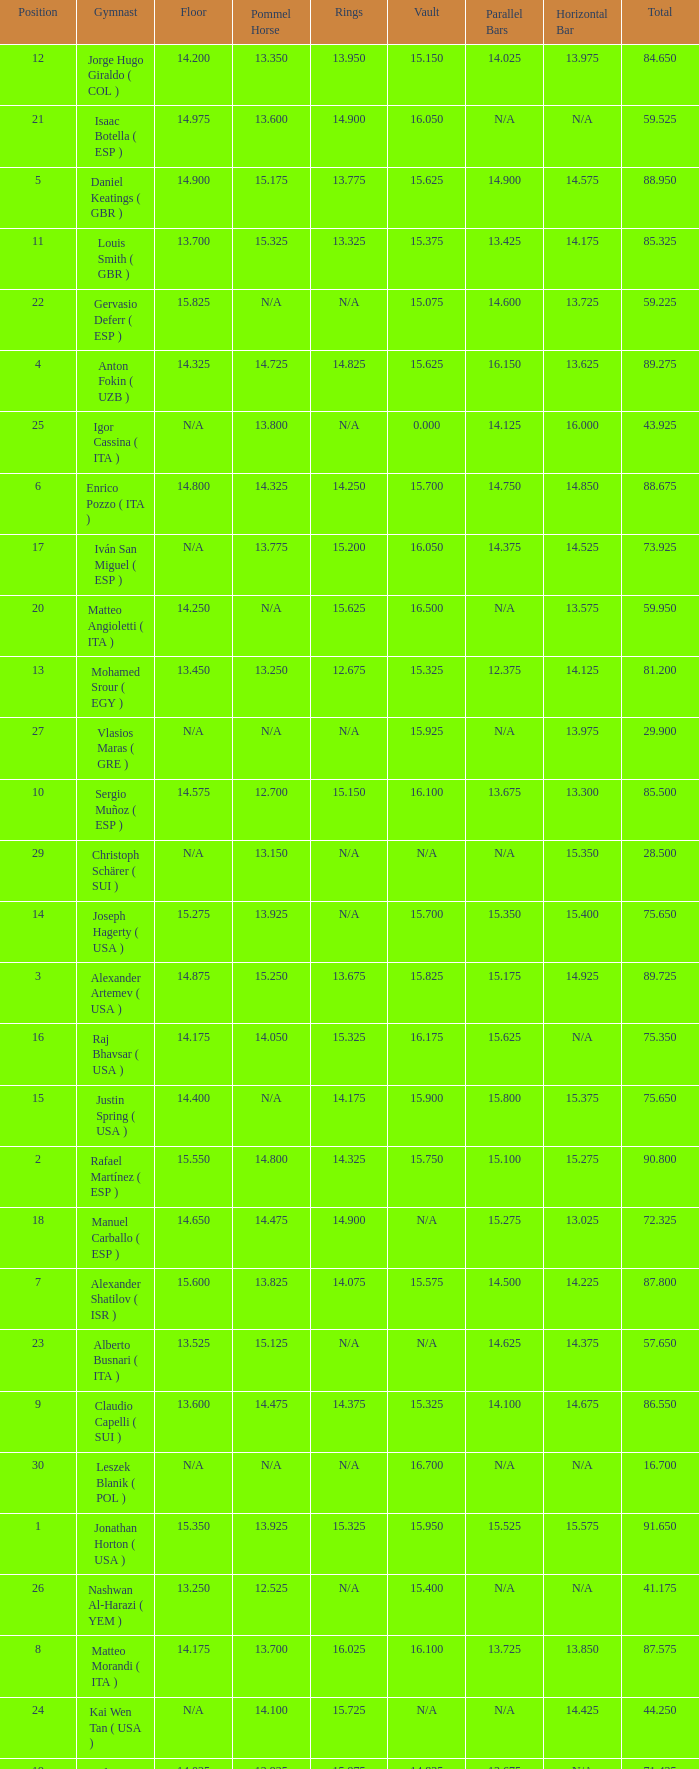Could you parse the entire table? {'header': ['Position', 'Gymnast', 'Floor', 'Pommel Horse', 'Rings', 'Vault', 'Parallel Bars', 'Horizontal Bar', 'Total'], 'rows': [['12', 'Jorge Hugo Giraldo ( COL )', '14.200', '13.350', '13.950', '15.150', '14.025', '13.975', '84.650'], ['21', 'Isaac Botella ( ESP )', '14.975', '13.600', '14.900', '16.050', 'N/A', 'N/A', '59.525'], ['5', 'Daniel Keatings ( GBR )', '14.900', '15.175', '13.775', '15.625', '14.900', '14.575', '88.950'], ['11', 'Louis Smith ( GBR )', '13.700', '15.325', '13.325', '15.375', '13.425', '14.175', '85.325'], ['22', 'Gervasio Deferr ( ESP )', '15.825', 'N/A', 'N/A', '15.075', '14.600', '13.725', '59.225'], ['4', 'Anton Fokin ( UZB )', '14.325', '14.725', '14.825', '15.625', '16.150', '13.625', '89.275'], ['25', 'Igor Cassina ( ITA )', 'N/A', '13.800', 'N/A', '0.000', '14.125', '16.000', '43.925'], ['6', 'Enrico Pozzo ( ITA )', '14.800', '14.325', '14.250', '15.700', '14.750', '14.850', '88.675'], ['17', 'Iván San Miguel ( ESP )', 'N/A', '13.775', '15.200', '16.050', '14.375', '14.525', '73.925'], ['20', 'Matteo Angioletti ( ITA )', '14.250', 'N/A', '15.625', '16.500', 'N/A', '13.575', '59.950'], ['13', 'Mohamed Srour ( EGY )', '13.450', '13.250', '12.675', '15.325', '12.375', '14.125', '81.200'], ['27', 'Vlasios Maras ( GRE )', 'N/A', 'N/A', 'N/A', '15.925', 'N/A', '13.975', '29.900'], ['10', 'Sergio Muñoz ( ESP )', '14.575', '12.700', '15.150', '16.100', '13.675', '13.300', '85.500'], ['29', 'Christoph Schärer ( SUI )', 'N/A', '13.150', 'N/A', 'N/A', 'N/A', '15.350', '28.500'], ['14', 'Joseph Hagerty ( USA )', '15.275', '13.925', 'N/A', '15.700', '15.350', '15.400', '75.650'], ['3', 'Alexander Artemev ( USA )', '14.875', '15.250', '13.675', '15.825', '15.175', '14.925', '89.725'], ['16', 'Raj Bhavsar ( USA )', '14.175', '14.050', '15.325', '16.175', '15.625', 'N/A', '75.350'], ['15', 'Justin Spring ( USA )', '14.400', 'N/A', '14.175', '15.900', '15.800', '15.375', '75.650'], ['2', 'Rafael Martínez ( ESP )', '15.550', '14.800', '14.325', '15.750', '15.100', '15.275', '90.800'], ['18', 'Manuel Carballo ( ESP )', '14.650', '14.475', '14.900', 'N/A', '15.275', '13.025', '72.325'], ['7', 'Alexander Shatilov ( ISR )', '15.600', '13.825', '14.075', '15.575', '14.500', '14.225', '87.800'], ['23', 'Alberto Busnari ( ITA )', '13.525', '15.125', 'N/A', 'N/A', '14.625', '14.375', '57.650'], ['9', 'Claudio Capelli ( SUI )', '13.600', '14.475', '14.375', '15.325', '14.100', '14.675', '86.550'], ['30', 'Leszek Blanik ( POL )', 'N/A', 'N/A', 'N/A', '16.700', 'N/A', 'N/A', '16.700'], ['1', 'Jonathan Horton ( USA )', '15.350', '13.925', '15.325', '15.950', '15.525', '15.575', '91.650'], ['26', 'Nashwan Al-Harazi ( YEM )', '13.250', '12.525', 'N/A', '15.400', 'N/A', 'N/A', '41.175'], ['8', 'Matteo Morandi ( ITA )', '14.175', '13.700', '16.025', '16.100', '13.725', '13.850', '87.575'], ['24', 'Kai Wen Tan ( USA )', 'N/A', '14.100', '15.725', 'N/A', 'N/A', '14.425', '44.250'], ['19', 'Andrea Coppolino ( ITA )', '14.025', '12.925', '15.975', '14.825', '13.675', 'N/A', '71.425'], ['28', 'Ilia Giorgadze ( GEO )', '14.625', 'N/A', 'N/A', 'N/A', '15.150', 'N/A', '29.775']]} If the horizontal bar is n/a and the floor is 14.175, what is the number for the parallel bars? 15.625. 